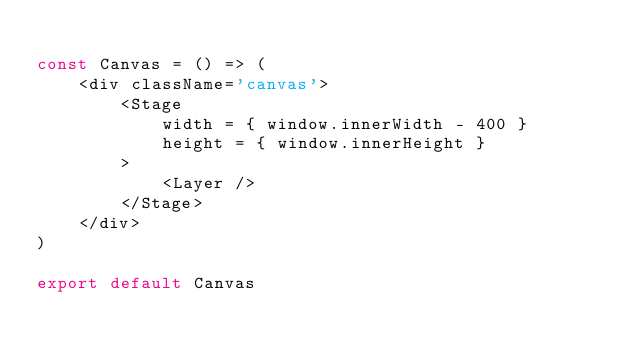<code> <loc_0><loc_0><loc_500><loc_500><_JavaScript_>
const Canvas = () => (
    <div className='canvas'>
        <Stage
            width = { window.innerWidth - 400 }
            height = { window.innerHeight }
        >
            <Layer />
        </Stage>
    </div>
)

export default Canvas</code> 